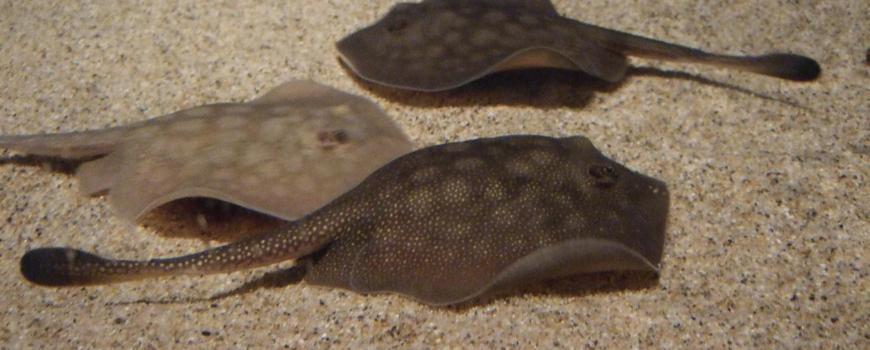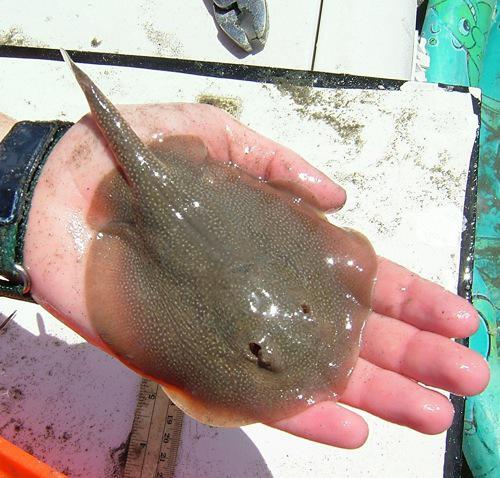The first image is the image on the left, the second image is the image on the right. Examine the images to the left and right. Is the description "All the rays are under water." accurate? Answer yes or no. No. The first image is the image on the left, the second image is the image on the right. Examine the images to the left and right. Is the description "The left and right image contains the same number of stingrays swimming facing slightly different directions." accurate? Answer yes or no. No. 